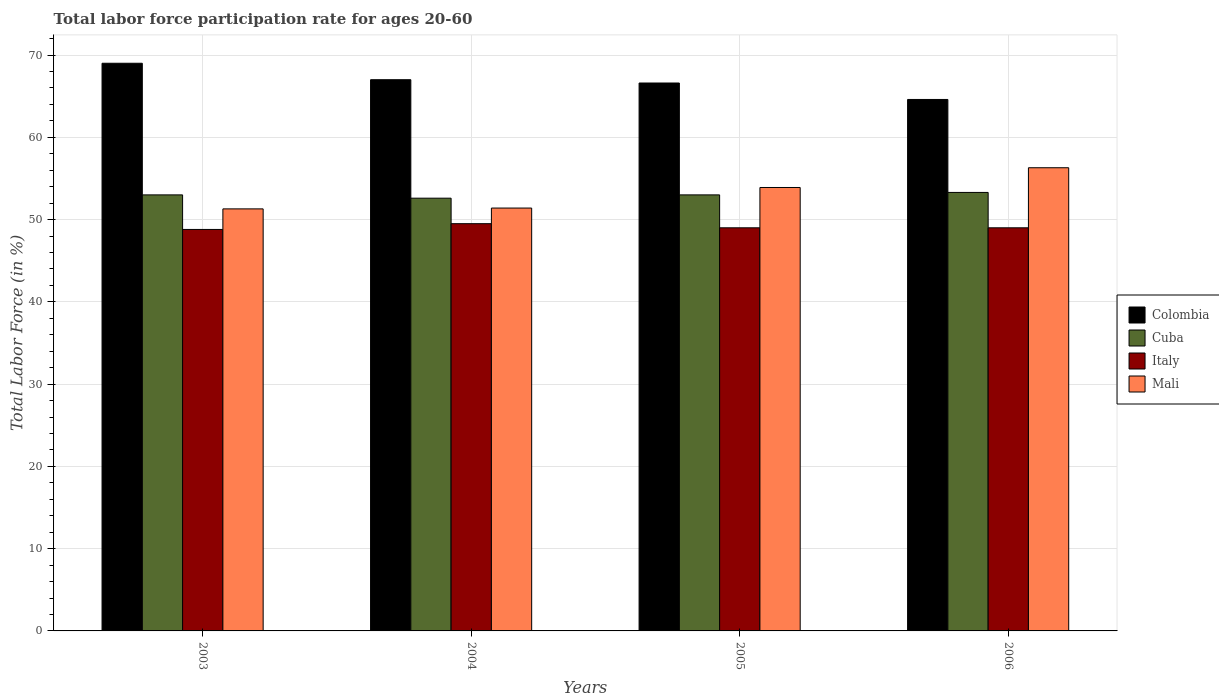Are the number of bars per tick equal to the number of legend labels?
Provide a short and direct response. Yes. Are the number of bars on each tick of the X-axis equal?
Make the answer very short. Yes. How many bars are there on the 3rd tick from the left?
Provide a succinct answer. 4. In how many cases, is the number of bars for a given year not equal to the number of legend labels?
Your answer should be compact. 0. What is the labor force participation rate in Cuba in 2003?
Keep it short and to the point. 53. Across all years, what is the maximum labor force participation rate in Mali?
Your answer should be compact. 56.3. Across all years, what is the minimum labor force participation rate in Mali?
Give a very brief answer. 51.3. In which year was the labor force participation rate in Cuba minimum?
Ensure brevity in your answer.  2004. What is the total labor force participation rate in Italy in the graph?
Ensure brevity in your answer.  196.3. What is the difference between the labor force participation rate in Mali in 2004 and that in 2006?
Ensure brevity in your answer.  -4.9. What is the difference between the labor force participation rate in Mali in 2005 and the labor force participation rate in Colombia in 2006?
Give a very brief answer. -10.7. What is the average labor force participation rate in Colombia per year?
Your answer should be compact. 66.8. In the year 2006, what is the difference between the labor force participation rate in Cuba and labor force participation rate in Colombia?
Your answer should be compact. -11.3. What is the ratio of the labor force participation rate in Colombia in 2004 to that in 2005?
Your response must be concise. 1.01. Is the difference between the labor force participation rate in Cuba in 2003 and 2004 greater than the difference between the labor force participation rate in Colombia in 2003 and 2004?
Provide a short and direct response. No. What is the difference between the highest and the second highest labor force participation rate in Cuba?
Offer a very short reply. 0.3. What is the difference between the highest and the lowest labor force participation rate in Mali?
Your answer should be compact. 5. Is the sum of the labor force participation rate in Mali in 2003 and 2006 greater than the maximum labor force participation rate in Italy across all years?
Ensure brevity in your answer.  Yes. Is it the case that in every year, the sum of the labor force participation rate in Cuba and labor force participation rate in Italy is greater than the sum of labor force participation rate in Colombia and labor force participation rate in Mali?
Ensure brevity in your answer.  No. What does the 3rd bar from the right in 2005 represents?
Keep it short and to the point. Cuba. Is it the case that in every year, the sum of the labor force participation rate in Italy and labor force participation rate in Colombia is greater than the labor force participation rate in Mali?
Provide a short and direct response. Yes. Are all the bars in the graph horizontal?
Provide a short and direct response. No. How many years are there in the graph?
Keep it short and to the point. 4. What is the difference between two consecutive major ticks on the Y-axis?
Keep it short and to the point. 10. Does the graph contain any zero values?
Offer a very short reply. No. How many legend labels are there?
Your answer should be compact. 4. How are the legend labels stacked?
Ensure brevity in your answer.  Vertical. What is the title of the graph?
Provide a short and direct response. Total labor force participation rate for ages 20-60. What is the label or title of the X-axis?
Provide a succinct answer. Years. What is the Total Labor Force (in %) of Cuba in 2003?
Provide a succinct answer. 53. What is the Total Labor Force (in %) in Italy in 2003?
Provide a succinct answer. 48.8. What is the Total Labor Force (in %) of Mali in 2003?
Offer a very short reply. 51.3. What is the Total Labor Force (in %) of Colombia in 2004?
Offer a very short reply. 67. What is the Total Labor Force (in %) of Cuba in 2004?
Your answer should be compact. 52.6. What is the Total Labor Force (in %) of Italy in 2004?
Give a very brief answer. 49.5. What is the Total Labor Force (in %) in Mali in 2004?
Offer a very short reply. 51.4. What is the Total Labor Force (in %) of Colombia in 2005?
Offer a very short reply. 66.6. What is the Total Labor Force (in %) of Mali in 2005?
Provide a succinct answer. 53.9. What is the Total Labor Force (in %) of Colombia in 2006?
Keep it short and to the point. 64.6. What is the Total Labor Force (in %) of Cuba in 2006?
Ensure brevity in your answer.  53.3. What is the Total Labor Force (in %) in Mali in 2006?
Offer a very short reply. 56.3. Across all years, what is the maximum Total Labor Force (in %) in Cuba?
Make the answer very short. 53.3. Across all years, what is the maximum Total Labor Force (in %) in Italy?
Your answer should be very brief. 49.5. Across all years, what is the maximum Total Labor Force (in %) in Mali?
Your answer should be very brief. 56.3. Across all years, what is the minimum Total Labor Force (in %) in Colombia?
Keep it short and to the point. 64.6. Across all years, what is the minimum Total Labor Force (in %) in Cuba?
Make the answer very short. 52.6. Across all years, what is the minimum Total Labor Force (in %) in Italy?
Your response must be concise. 48.8. Across all years, what is the minimum Total Labor Force (in %) in Mali?
Offer a terse response. 51.3. What is the total Total Labor Force (in %) of Colombia in the graph?
Your response must be concise. 267.2. What is the total Total Labor Force (in %) in Cuba in the graph?
Provide a succinct answer. 211.9. What is the total Total Labor Force (in %) in Italy in the graph?
Keep it short and to the point. 196.3. What is the total Total Labor Force (in %) of Mali in the graph?
Offer a very short reply. 212.9. What is the difference between the Total Labor Force (in %) of Colombia in 2003 and that in 2004?
Your response must be concise. 2. What is the difference between the Total Labor Force (in %) of Italy in 2003 and that in 2004?
Offer a very short reply. -0.7. What is the difference between the Total Labor Force (in %) in Cuba in 2003 and that in 2005?
Your response must be concise. 0. What is the difference between the Total Labor Force (in %) of Italy in 2003 and that in 2005?
Your response must be concise. -0.2. What is the difference between the Total Labor Force (in %) of Mali in 2003 and that in 2005?
Ensure brevity in your answer.  -2.6. What is the difference between the Total Labor Force (in %) in Colombia in 2003 and that in 2006?
Offer a very short reply. 4.4. What is the difference between the Total Labor Force (in %) of Italy in 2004 and that in 2005?
Offer a very short reply. 0.5. What is the difference between the Total Labor Force (in %) in Mali in 2004 and that in 2005?
Provide a short and direct response. -2.5. What is the difference between the Total Labor Force (in %) in Italy in 2004 and that in 2006?
Your answer should be compact. 0.5. What is the difference between the Total Labor Force (in %) in Mali in 2004 and that in 2006?
Provide a succinct answer. -4.9. What is the difference between the Total Labor Force (in %) of Colombia in 2005 and that in 2006?
Ensure brevity in your answer.  2. What is the difference between the Total Labor Force (in %) in Italy in 2005 and that in 2006?
Provide a succinct answer. 0. What is the difference between the Total Labor Force (in %) in Mali in 2005 and that in 2006?
Keep it short and to the point. -2.4. What is the difference between the Total Labor Force (in %) of Colombia in 2003 and the Total Labor Force (in %) of Cuba in 2004?
Your answer should be very brief. 16.4. What is the difference between the Total Labor Force (in %) in Colombia in 2003 and the Total Labor Force (in %) in Italy in 2004?
Ensure brevity in your answer.  19.5. What is the difference between the Total Labor Force (in %) of Cuba in 2003 and the Total Labor Force (in %) of Italy in 2004?
Your response must be concise. 3.5. What is the difference between the Total Labor Force (in %) of Colombia in 2003 and the Total Labor Force (in %) of Mali in 2005?
Provide a succinct answer. 15.1. What is the difference between the Total Labor Force (in %) in Cuba in 2003 and the Total Labor Force (in %) in Italy in 2005?
Your answer should be very brief. 4. What is the difference between the Total Labor Force (in %) of Cuba in 2003 and the Total Labor Force (in %) of Mali in 2005?
Provide a short and direct response. -0.9. What is the difference between the Total Labor Force (in %) in Colombia in 2003 and the Total Labor Force (in %) in Mali in 2006?
Ensure brevity in your answer.  12.7. What is the difference between the Total Labor Force (in %) in Cuba in 2003 and the Total Labor Force (in %) in Mali in 2006?
Your response must be concise. -3.3. What is the difference between the Total Labor Force (in %) in Colombia in 2004 and the Total Labor Force (in %) in Cuba in 2005?
Ensure brevity in your answer.  14. What is the difference between the Total Labor Force (in %) of Colombia in 2004 and the Total Labor Force (in %) of Italy in 2005?
Provide a short and direct response. 18. What is the difference between the Total Labor Force (in %) of Colombia in 2004 and the Total Labor Force (in %) of Mali in 2005?
Offer a very short reply. 13.1. What is the difference between the Total Labor Force (in %) in Italy in 2004 and the Total Labor Force (in %) in Mali in 2005?
Give a very brief answer. -4.4. What is the difference between the Total Labor Force (in %) in Colombia in 2004 and the Total Labor Force (in %) in Cuba in 2006?
Your response must be concise. 13.7. What is the difference between the Total Labor Force (in %) of Cuba in 2004 and the Total Labor Force (in %) of Italy in 2006?
Keep it short and to the point. 3.6. What is the difference between the Total Labor Force (in %) of Cuba in 2004 and the Total Labor Force (in %) of Mali in 2006?
Provide a succinct answer. -3.7. What is the difference between the Total Labor Force (in %) of Colombia in 2005 and the Total Labor Force (in %) of Cuba in 2006?
Your response must be concise. 13.3. What is the difference between the Total Labor Force (in %) in Colombia in 2005 and the Total Labor Force (in %) in Mali in 2006?
Ensure brevity in your answer.  10.3. What is the difference between the Total Labor Force (in %) of Cuba in 2005 and the Total Labor Force (in %) of Mali in 2006?
Give a very brief answer. -3.3. What is the average Total Labor Force (in %) of Colombia per year?
Make the answer very short. 66.8. What is the average Total Labor Force (in %) in Cuba per year?
Keep it short and to the point. 52.98. What is the average Total Labor Force (in %) in Italy per year?
Keep it short and to the point. 49.08. What is the average Total Labor Force (in %) in Mali per year?
Provide a short and direct response. 53.23. In the year 2003, what is the difference between the Total Labor Force (in %) of Colombia and Total Labor Force (in %) of Cuba?
Ensure brevity in your answer.  16. In the year 2003, what is the difference between the Total Labor Force (in %) of Colombia and Total Labor Force (in %) of Italy?
Keep it short and to the point. 20.2. In the year 2003, what is the difference between the Total Labor Force (in %) in Cuba and Total Labor Force (in %) in Mali?
Ensure brevity in your answer.  1.7. In the year 2004, what is the difference between the Total Labor Force (in %) of Cuba and Total Labor Force (in %) of Italy?
Provide a succinct answer. 3.1. In the year 2004, what is the difference between the Total Labor Force (in %) of Italy and Total Labor Force (in %) of Mali?
Provide a succinct answer. -1.9. In the year 2005, what is the difference between the Total Labor Force (in %) of Colombia and Total Labor Force (in %) of Mali?
Offer a very short reply. 12.7. In the year 2005, what is the difference between the Total Labor Force (in %) of Cuba and Total Labor Force (in %) of Mali?
Give a very brief answer. -0.9. In the year 2006, what is the difference between the Total Labor Force (in %) in Colombia and Total Labor Force (in %) in Mali?
Your answer should be very brief. 8.3. What is the ratio of the Total Labor Force (in %) in Colombia in 2003 to that in 2004?
Keep it short and to the point. 1.03. What is the ratio of the Total Labor Force (in %) of Cuba in 2003 to that in 2004?
Give a very brief answer. 1.01. What is the ratio of the Total Labor Force (in %) in Italy in 2003 to that in 2004?
Your response must be concise. 0.99. What is the ratio of the Total Labor Force (in %) in Mali in 2003 to that in 2004?
Your answer should be very brief. 1. What is the ratio of the Total Labor Force (in %) of Colombia in 2003 to that in 2005?
Offer a terse response. 1.04. What is the ratio of the Total Labor Force (in %) of Mali in 2003 to that in 2005?
Give a very brief answer. 0.95. What is the ratio of the Total Labor Force (in %) of Colombia in 2003 to that in 2006?
Provide a succinct answer. 1.07. What is the ratio of the Total Labor Force (in %) in Italy in 2003 to that in 2006?
Your response must be concise. 1. What is the ratio of the Total Labor Force (in %) of Mali in 2003 to that in 2006?
Ensure brevity in your answer.  0.91. What is the ratio of the Total Labor Force (in %) of Colombia in 2004 to that in 2005?
Your answer should be compact. 1.01. What is the ratio of the Total Labor Force (in %) of Italy in 2004 to that in 2005?
Ensure brevity in your answer.  1.01. What is the ratio of the Total Labor Force (in %) in Mali in 2004 to that in 2005?
Your response must be concise. 0.95. What is the ratio of the Total Labor Force (in %) of Colombia in 2004 to that in 2006?
Give a very brief answer. 1.04. What is the ratio of the Total Labor Force (in %) of Cuba in 2004 to that in 2006?
Make the answer very short. 0.99. What is the ratio of the Total Labor Force (in %) of Italy in 2004 to that in 2006?
Your answer should be very brief. 1.01. What is the ratio of the Total Labor Force (in %) in Mali in 2004 to that in 2006?
Keep it short and to the point. 0.91. What is the ratio of the Total Labor Force (in %) of Colombia in 2005 to that in 2006?
Ensure brevity in your answer.  1.03. What is the ratio of the Total Labor Force (in %) in Italy in 2005 to that in 2006?
Offer a very short reply. 1. What is the ratio of the Total Labor Force (in %) of Mali in 2005 to that in 2006?
Your answer should be very brief. 0.96. What is the difference between the highest and the lowest Total Labor Force (in %) of Colombia?
Your response must be concise. 4.4. What is the difference between the highest and the lowest Total Labor Force (in %) in Cuba?
Keep it short and to the point. 0.7. What is the difference between the highest and the lowest Total Labor Force (in %) in Italy?
Provide a short and direct response. 0.7. 